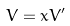<formula> <loc_0><loc_0><loc_500><loc_500>V = x V ^ { \prime }</formula> 